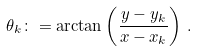<formula> <loc_0><loc_0><loc_500><loc_500>\theta _ { k } \colon = \arctan \left ( \frac { y - y _ { k } } { x - x _ { k } } \right ) \, .</formula> 